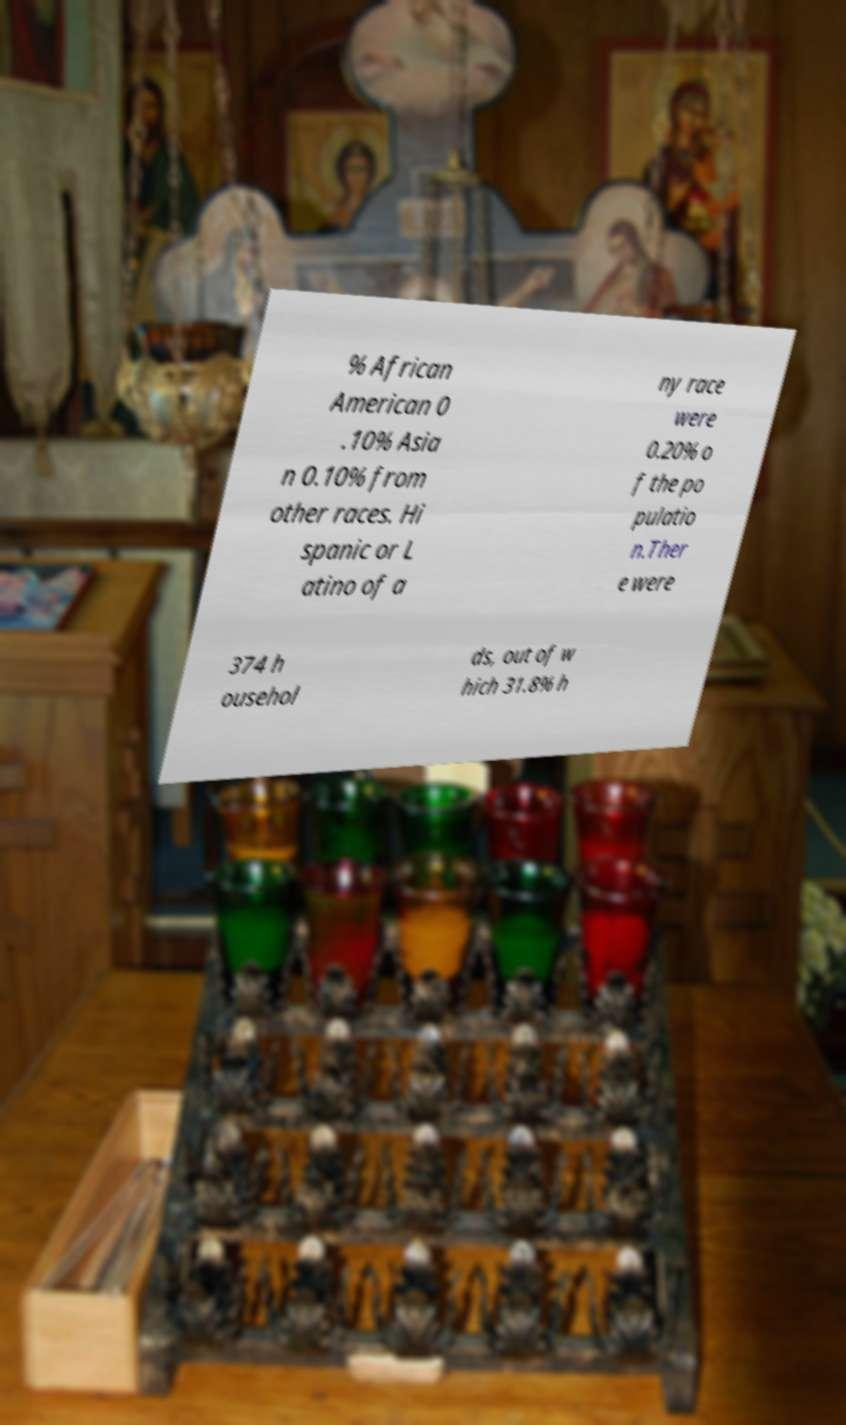Please identify and transcribe the text found in this image. % African American 0 .10% Asia n 0.10% from other races. Hi spanic or L atino of a ny race were 0.20% o f the po pulatio n.Ther e were 374 h ousehol ds, out of w hich 31.8% h 